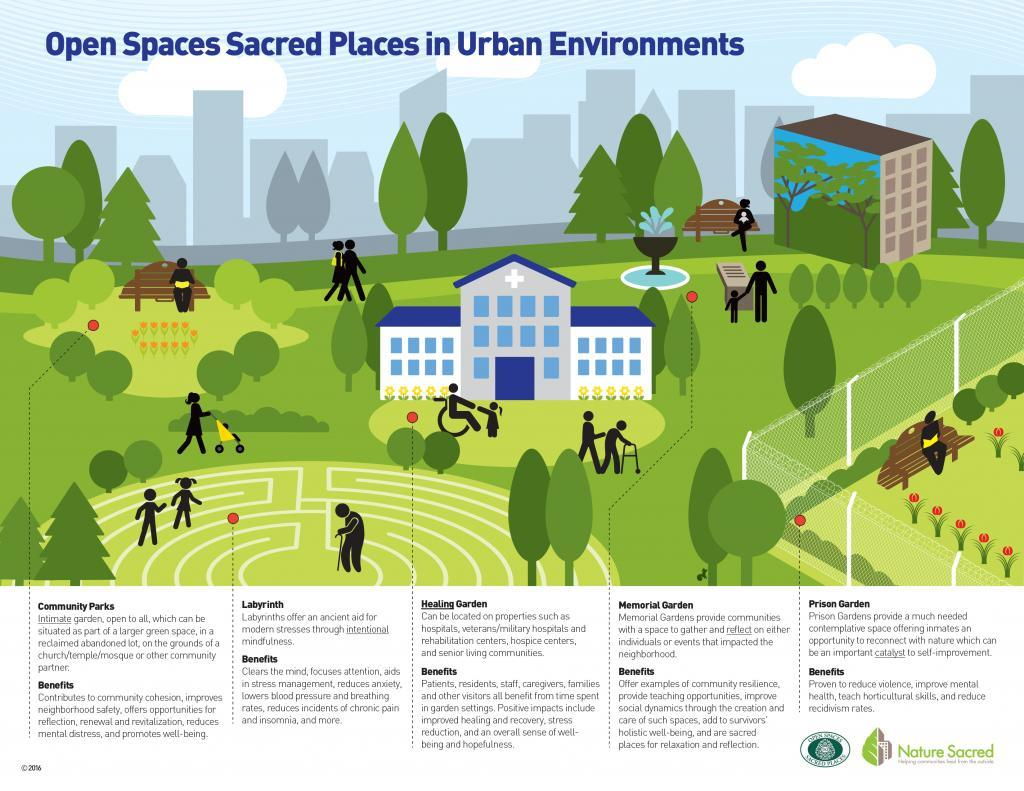How many people including babies and kids are shown in the infographic?
Answer the question with a short phrase. 17 